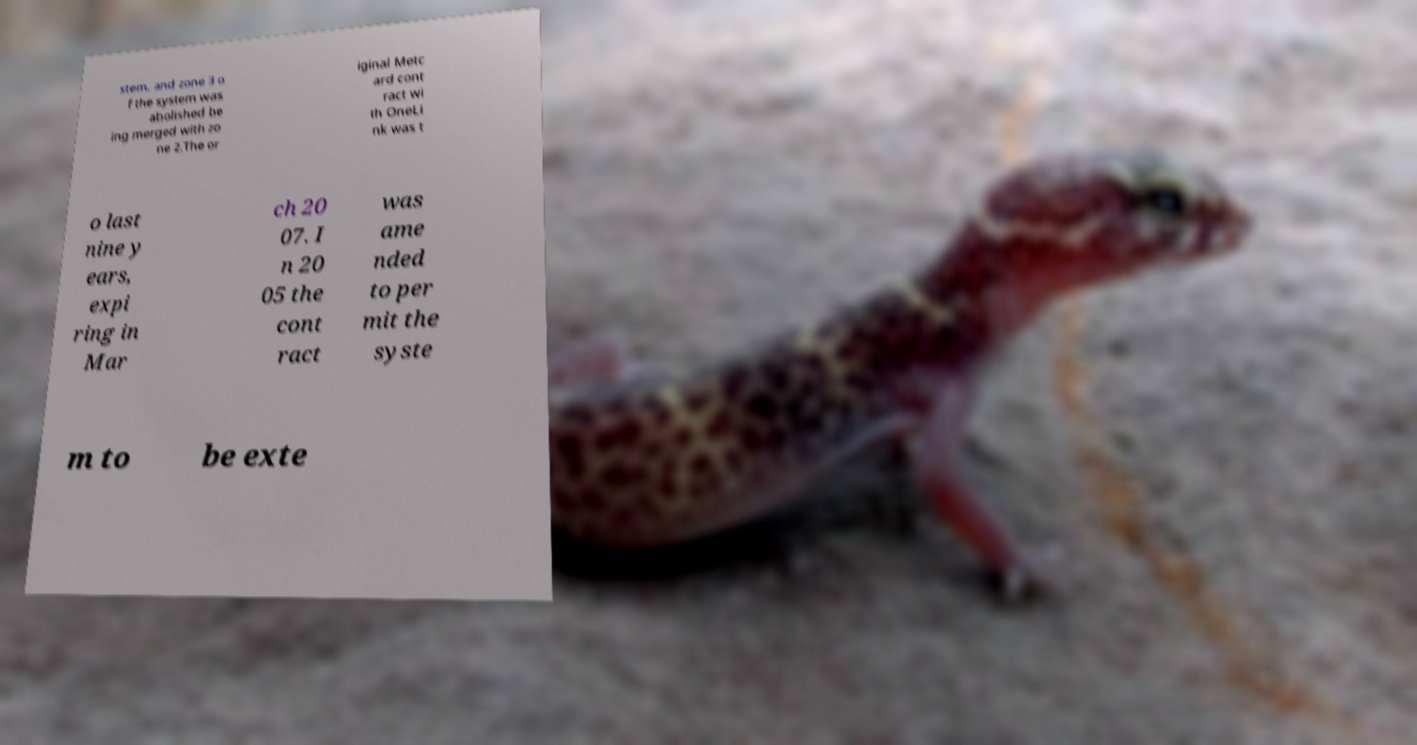Please read and relay the text visible in this image. What does it say? stem. and zone 3 o f the system was abolished be ing merged with zo ne 2.The or iginal Metc ard cont ract wi th OneLi nk was t o last nine y ears, expi ring in Mar ch 20 07. I n 20 05 the cont ract was ame nded to per mit the syste m to be exte 